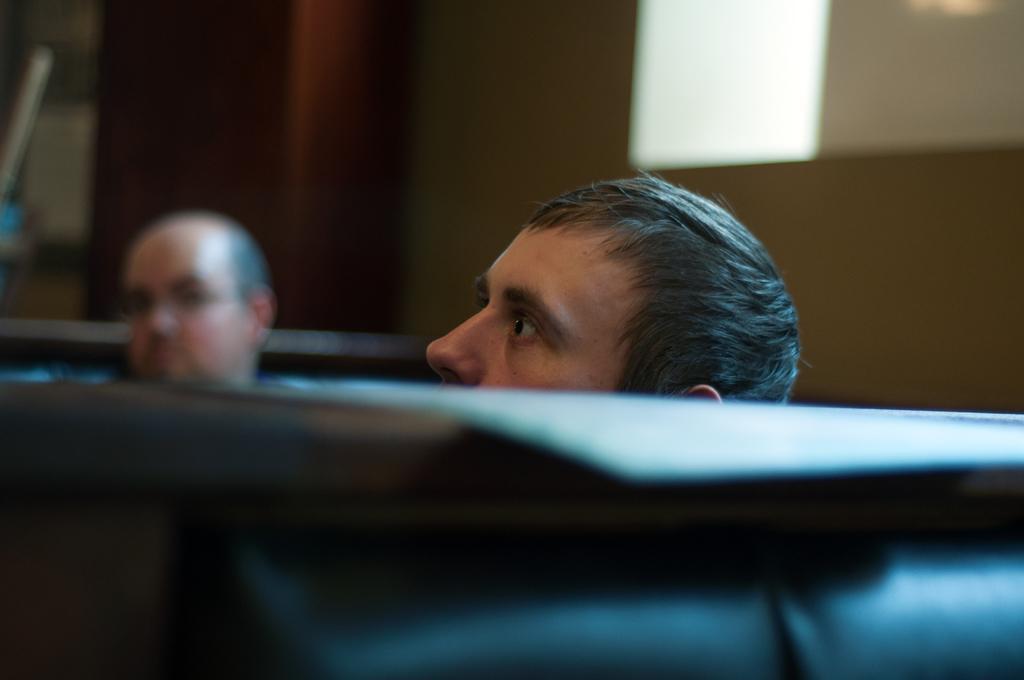In one or two sentences, can you explain what this image depicts? In the center of this picture we can see the two persons and some other objects. In the background we can see some other objects. 